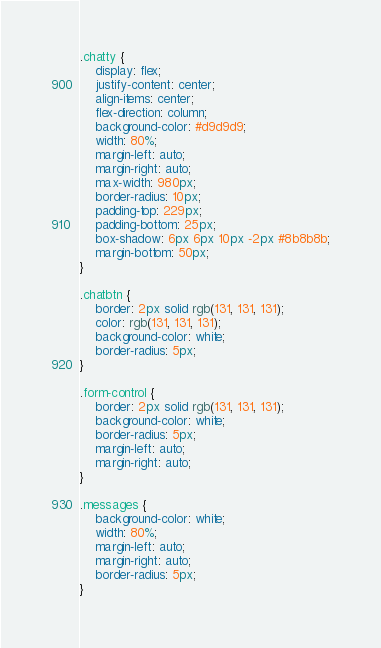Convert code to text. <code><loc_0><loc_0><loc_500><loc_500><_CSS_>.chatty {
    display: flex;
    justify-content: center;
    align-items: center;
    flex-direction: column;
    background-color: #d9d9d9;
    width: 80%;
    margin-left: auto;
    margin-right: auto;
    max-width: 980px;
    border-radius: 10px;
    padding-top: 229px;
    padding-bottom: 25px;
    box-shadow: 6px 6px 10px -2px #8b8b8b;
    margin-bottom: 50px;
}

.chatbtn {
    border: 2px solid rgb(131, 131, 131);
    color: rgb(131, 131, 131);
    background-color: white;
    border-radius: 5px;
}

.form-control {
    border: 2px solid rgb(131, 131, 131);
    background-color: white;
    border-radius: 5px;
    margin-left: auto;
    margin-right: auto;
}

.messages {
    background-color: white;
    width: 80%;
    margin-left: auto;
    margin-right: auto;
    border-radius: 5px;
}</code> 